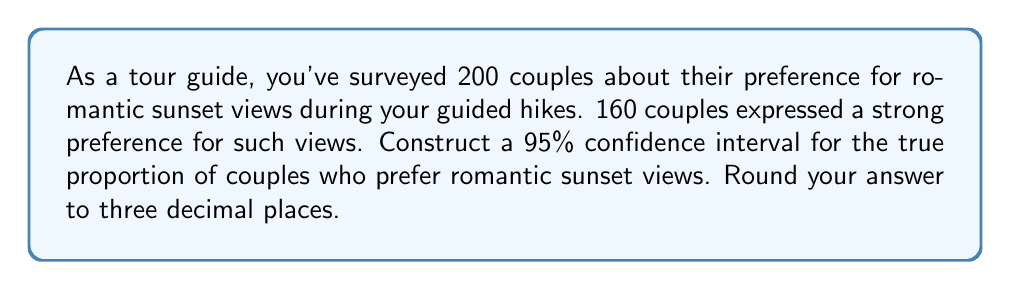Help me with this question. Let's approach this step-by-step:

1) We're dealing with a proportion, so we'll use the formula for a confidence interval for a proportion:

   $$\hat{p} \pm z^* \sqrt{\frac{\hat{p}(1-\hat{p})}{n}}$$

   where $\hat{p}$ is the sample proportion, $z^*$ is the critical value, and $n$ is the sample size.

2) Calculate $\hat{p}$:
   $$\hat{p} = \frac{160}{200} = 0.8$$

3) For a 95% confidence interval, $z^* = 1.96$

4) Calculate the standard error:
   $$SE = \sqrt{\frac{\hat{p}(1-\hat{p})}{n}} = \sqrt{\frac{0.8(1-0.8)}{200}} = \sqrt{\frac{0.16}{200}} = 0.0283$$

5) Now, let's calculate the margin of error:
   $$ME = z^* \times SE = 1.96 \times 0.0283 = 0.0554$$

6) The confidence interval is:
   $$0.8 \pm 0.0554$$

7) Therefore, the interval is:
   $$(0.8 - 0.0554, 0.8 + 0.0554) = (0.7446, 0.8554)$$

8) Rounding to three decimal places:
   $$(0.745, 0.855)$$
Answer: (0.745, 0.855) 